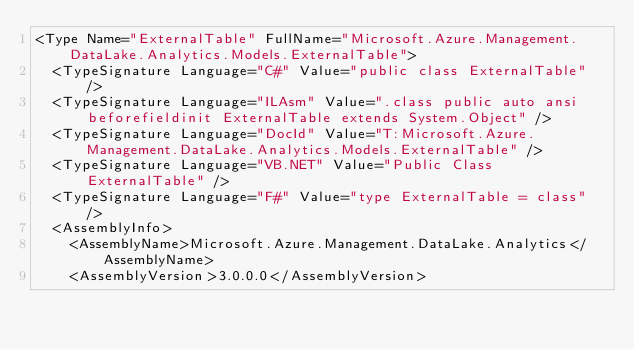Convert code to text. <code><loc_0><loc_0><loc_500><loc_500><_XML_><Type Name="ExternalTable" FullName="Microsoft.Azure.Management.DataLake.Analytics.Models.ExternalTable">
  <TypeSignature Language="C#" Value="public class ExternalTable" />
  <TypeSignature Language="ILAsm" Value=".class public auto ansi beforefieldinit ExternalTable extends System.Object" />
  <TypeSignature Language="DocId" Value="T:Microsoft.Azure.Management.DataLake.Analytics.Models.ExternalTable" />
  <TypeSignature Language="VB.NET" Value="Public Class ExternalTable" />
  <TypeSignature Language="F#" Value="type ExternalTable = class" />
  <AssemblyInfo>
    <AssemblyName>Microsoft.Azure.Management.DataLake.Analytics</AssemblyName>
    <AssemblyVersion>3.0.0.0</AssemblyVersion></code> 